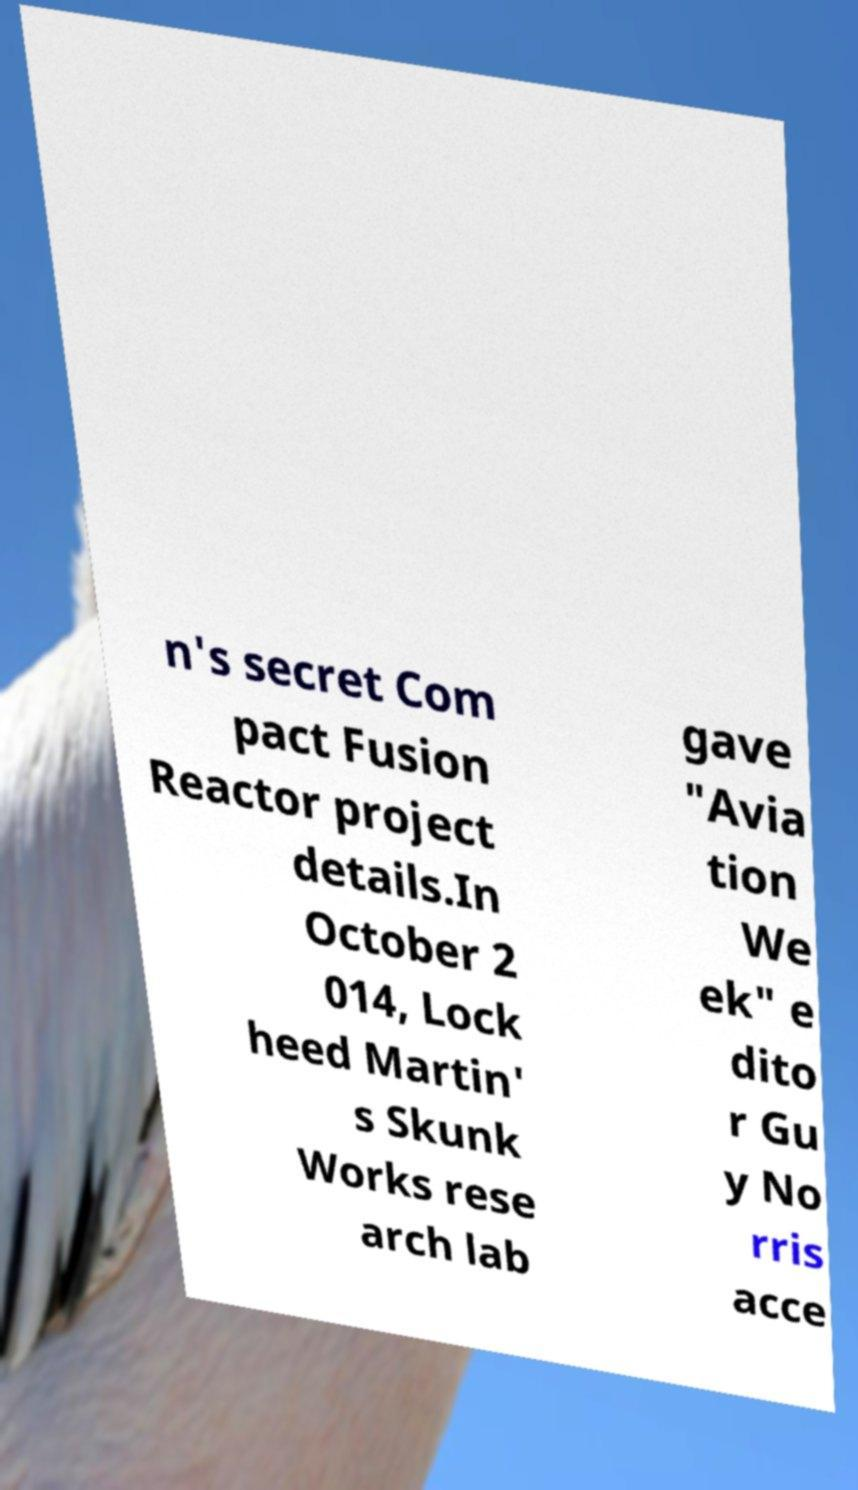Please read and relay the text visible in this image. What does it say? n's secret Com pact Fusion Reactor project details.In October 2 014, Lock heed Martin' s Skunk Works rese arch lab gave "Avia tion We ek" e dito r Gu y No rris acce 